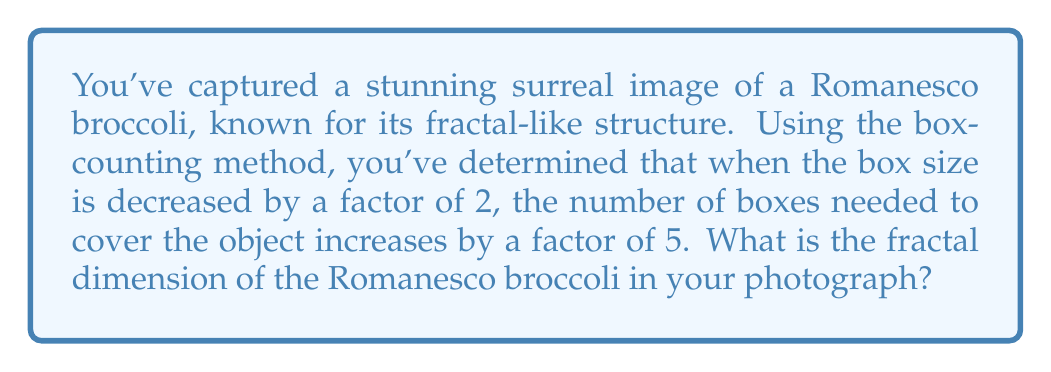Give your solution to this math problem. To determine the fractal dimension using the box-counting method, we follow these steps:

1. Let's define our variables:
   $r$ = scaling factor (ratio of box sizes)
   $N$ = ratio of number of boxes

2. In this case:
   $r = \frac{1}{2}$ (box size decreased by factor of 2)
   $N = 5$ (number of boxes increased by factor of 5)

3. The fractal dimension $D$ is given by the formula:

   $$D = \frac{\log N}{\log(\frac{1}{r})}$$

4. Substituting our values:

   $$D = \frac{\log 5}{\log(\frac{1}{\frac{1}{2}})} = \frac{\log 5}{\log 2}$$

5. Calculate:
   $$D = \frac{\log 5}{\log 2} \approx 2.3219$$

6. Round to two decimal places:
   $$D \approx 2.32$$

This fractal dimension indicates that the Romanesco broccoli in your photograph has a complexity between a 2D surface and a 3D object, which is characteristic of many natural fractals.
Answer: 2.32 